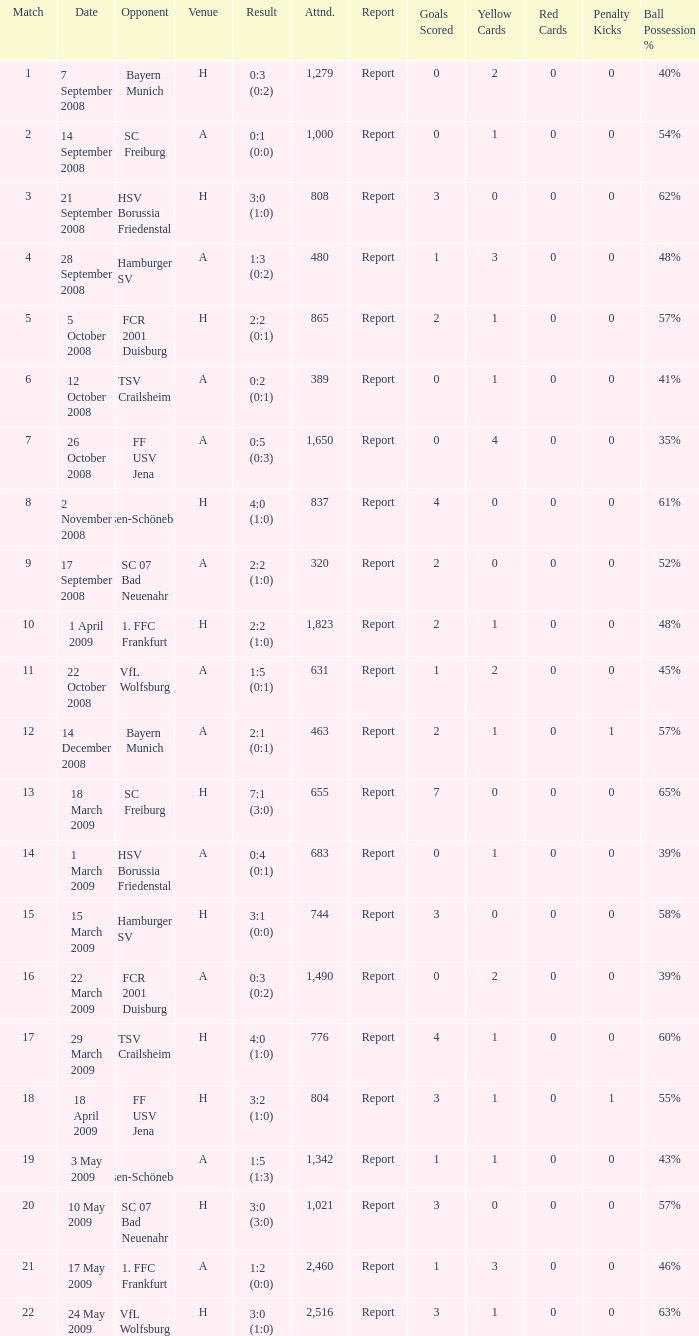When did fcr 2001 duisburg take part in a match as the adversary? 21.0. 